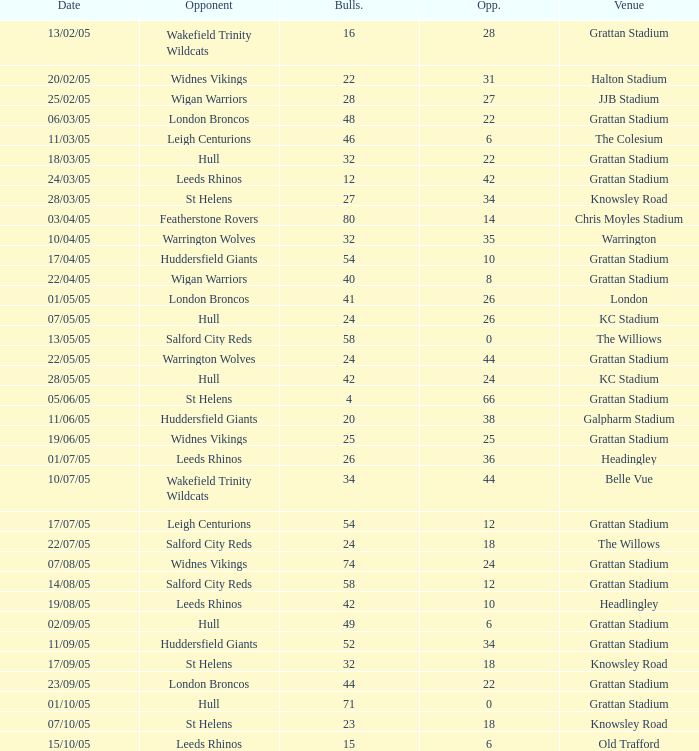What was the total number for the Bulls when they were at Old Trafford? 1.0. 